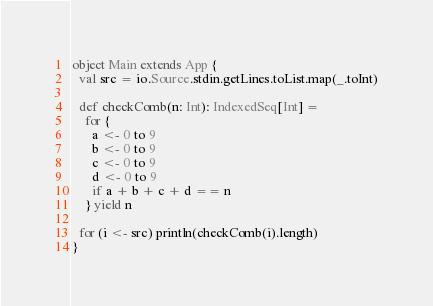Convert code to text. <code><loc_0><loc_0><loc_500><loc_500><_Scala_>object Main extends App {
  val src = io.Source.stdin.getLines.toList.map(_.toInt)

  def checkComb(n: Int): IndexedSeq[Int] =
    for {
      a <- 0 to 9
      b <- 0 to 9
      c <- 0 to 9
      d <- 0 to 9
      if a + b + c + d == n
    } yield n

  for (i <- src) println(checkComb(i).length)
}</code> 